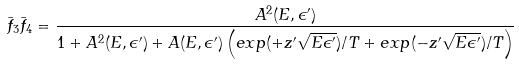Convert formula to latex. <formula><loc_0><loc_0><loc_500><loc_500>\bar { f } _ { 3 } \bar { f } _ { 4 } = \frac { A ^ { 2 } ( E , \epsilon ^ { \prime } ) } { 1 + A ^ { 2 } ( E , \epsilon ^ { \prime } ) + A ( E , \epsilon ^ { \prime } ) \left ( e x p ( + z ^ { \prime } \sqrt { E \epsilon ^ { \prime } } ) / T + e x p ( - z ^ { \prime } \sqrt { E \epsilon ^ { \prime } } ) / T \right ) }</formula> 